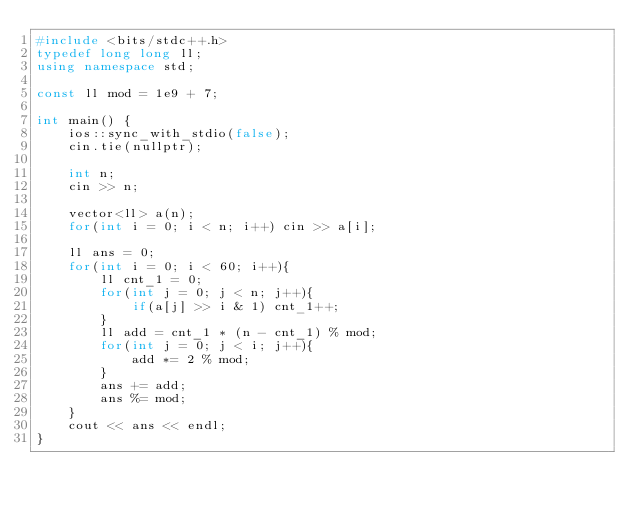<code> <loc_0><loc_0><loc_500><loc_500><_C++_>#include <bits/stdc++.h>
typedef long long ll;
using namespace std;

const ll mod = 1e9 + 7;

int main() {
    ios::sync_with_stdio(false);
    cin.tie(nullptr);

    int n;
    cin >> n;

    vector<ll> a(n);
    for(int i = 0; i < n; i++) cin >> a[i];

    ll ans = 0;
    for(int i = 0; i < 60; i++){
        ll cnt_1 = 0;
        for(int j = 0; j < n; j++){
            if(a[j] >> i & 1) cnt_1++;
        }
        ll add = cnt_1 * (n - cnt_1) % mod;
        for(int j = 0; j < i; j++){
            add *= 2 % mod;
        }
        ans += add;
        ans %= mod;
    }
    cout << ans << endl;
}</code> 